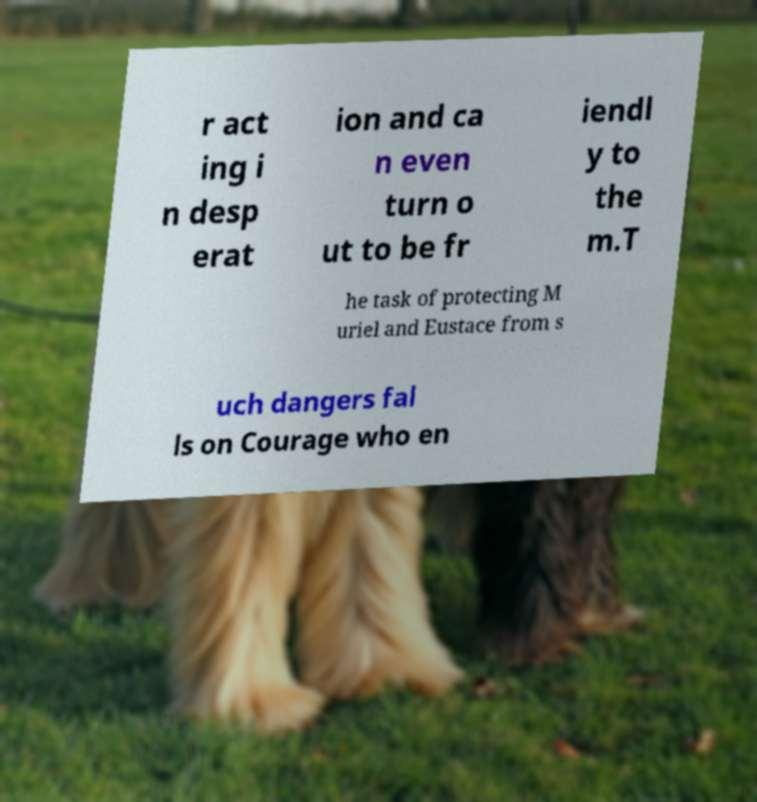I need the written content from this picture converted into text. Can you do that? r act ing i n desp erat ion and ca n even turn o ut to be fr iendl y to the m.T he task of protecting M uriel and Eustace from s uch dangers fal ls on Courage who en 